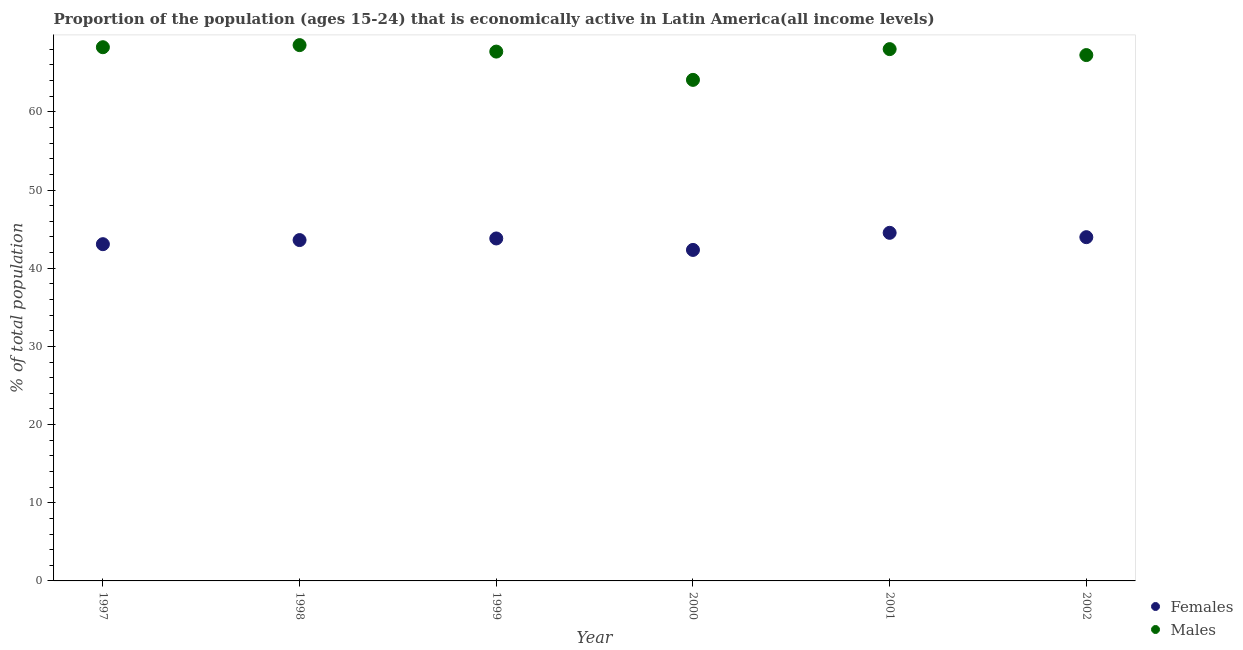How many different coloured dotlines are there?
Provide a succinct answer. 2. What is the percentage of economically active female population in 1998?
Offer a terse response. 43.6. Across all years, what is the maximum percentage of economically active female population?
Keep it short and to the point. 44.53. Across all years, what is the minimum percentage of economically active female population?
Offer a terse response. 42.34. What is the total percentage of economically active female population in the graph?
Ensure brevity in your answer.  261.32. What is the difference between the percentage of economically active male population in 1998 and that in 1999?
Keep it short and to the point. 0.83. What is the difference between the percentage of economically active male population in 1999 and the percentage of economically active female population in 2002?
Offer a very short reply. 23.74. What is the average percentage of economically active male population per year?
Provide a succinct answer. 67.32. In the year 1999, what is the difference between the percentage of economically active male population and percentage of economically active female population?
Your answer should be compact. 23.9. What is the ratio of the percentage of economically active female population in 1997 to that in 2001?
Keep it short and to the point. 0.97. What is the difference between the highest and the second highest percentage of economically active female population?
Give a very brief answer. 0.56. What is the difference between the highest and the lowest percentage of economically active male population?
Give a very brief answer. 4.45. Does the percentage of economically active female population monotonically increase over the years?
Your response must be concise. No. Is the percentage of economically active female population strictly less than the percentage of economically active male population over the years?
Your answer should be very brief. Yes. How many dotlines are there?
Give a very brief answer. 2. How many years are there in the graph?
Provide a succinct answer. 6. What is the difference between two consecutive major ticks on the Y-axis?
Ensure brevity in your answer.  10. Are the values on the major ticks of Y-axis written in scientific E-notation?
Offer a very short reply. No. Does the graph contain grids?
Give a very brief answer. No. What is the title of the graph?
Provide a succinct answer. Proportion of the population (ages 15-24) that is economically active in Latin America(all income levels). Does "External balance on goods" appear as one of the legend labels in the graph?
Your answer should be very brief. No. What is the label or title of the Y-axis?
Provide a succinct answer. % of total population. What is the % of total population in Females in 1997?
Give a very brief answer. 43.07. What is the % of total population in Males in 1997?
Your answer should be compact. 68.27. What is the % of total population in Females in 1998?
Your answer should be compact. 43.6. What is the % of total population in Males in 1998?
Provide a succinct answer. 68.54. What is the % of total population in Females in 1999?
Make the answer very short. 43.81. What is the % of total population in Males in 1999?
Keep it short and to the point. 67.71. What is the % of total population of Females in 2000?
Provide a short and direct response. 42.34. What is the % of total population of Males in 2000?
Give a very brief answer. 64.09. What is the % of total population of Females in 2001?
Offer a very short reply. 44.53. What is the % of total population of Males in 2001?
Offer a very short reply. 68.03. What is the % of total population in Females in 2002?
Your response must be concise. 43.97. What is the % of total population of Males in 2002?
Offer a terse response. 67.26. Across all years, what is the maximum % of total population in Females?
Provide a short and direct response. 44.53. Across all years, what is the maximum % of total population in Males?
Give a very brief answer. 68.54. Across all years, what is the minimum % of total population in Females?
Make the answer very short. 42.34. Across all years, what is the minimum % of total population in Males?
Your answer should be very brief. 64.09. What is the total % of total population in Females in the graph?
Offer a very short reply. 261.32. What is the total % of total population of Males in the graph?
Your response must be concise. 403.9. What is the difference between the % of total population in Females in 1997 and that in 1998?
Offer a very short reply. -0.53. What is the difference between the % of total population in Males in 1997 and that in 1998?
Your answer should be compact. -0.27. What is the difference between the % of total population of Females in 1997 and that in 1999?
Give a very brief answer. -0.73. What is the difference between the % of total population of Males in 1997 and that in 1999?
Your answer should be very brief. 0.56. What is the difference between the % of total population of Females in 1997 and that in 2000?
Your answer should be compact. 0.73. What is the difference between the % of total population in Males in 1997 and that in 2000?
Offer a very short reply. 4.18. What is the difference between the % of total population of Females in 1997 and that in 2001?
Keep it short and to the point. -1.45. What is the difference between the % of total population of Males in 1997 and that in 2001?
Provide a short and direct response. 0.24. What is the difference between the % of total population in Females in 1997 and that in 2002?
Give a very brief answer. -0.9. What is the difference between the % of total population in Females in 1998 and that in 1999?
Provide a succinct answer. -0.21. What is the difference between the % of total population of Males in 1998 and that in 1999?
Keep it short and to the point. 0.83. What is the difference between the % of total population of Females in 1998 and that in 2000?
Keep it short and to the point. 1.26. What is the difference between the % of total population in Males in 1998 and that in 2000?
Offer a very short reply. 4.45. What is the difference between the % of total population of Females in 1998 and that in 2001?
Your response must be concise. -0.93. What is the difference between the % of total population in Males in 1998 and that in 2001?
Your response must be concise. 0.51. What is the difference between the % of total population of Females in 1998 and that in 2002?
Make the answer very short. -0.37. What is the difference between the % of total population in Males in 1998 and that in 2002?
Give a very brief answer. 1.27. What is the difference between the % of total population of Females in 1999 and that in 2000?
Your answer should be compact. 1.47. What is the difference between the % of total population in Males in 1999 and that in 2000?
Ensure brevity in your answer.  3.62. What is the difference between the % of total population in Females in 1999 and that in 2001?
Keep it short and to the point. -0.72. What is the difference between the % of total population of Males in 1999 and that in 2001?
Your response must be concise. -0.32. What is the difference between the % of total population in Females in 1999 and that in 2002?
Give a very brief answer. -0.17. What is the difference between the % of total population of Males in 1999 and that in 2002?
Your answer should be compact. 0.44. What is the difference between the % of total population of Females in 2000 and that in 2001?
Provide a succinct answer. -2.19. What is the difference between the % of total population in Males in 2000 and that in 2001?
Keep it short and to the point. -3.93. What is the difference between the % of total population in Females in 2000 and that in 2002?
Make the answer very short. -1.63. What is the difference between the % of total population of Males in 2000 and that in 2002?
Offer a terse response. -3.17. What is the difference between the % of total population in Females in 2001 and that in 2002?
Your answer should be compact. 0.56. What is the difference between the % of total population in Males in 2001 and that in 2002?
Keep it short and to the point. 0.76. What is the difference between the % of total population in Females in 1997 and the % of total population in Males in 1998?
Your answer should be compact. -25.46. What is the difference between the % of total population in Females in 1997 and the % of total population in Males in 1999?
Offer a terse response. -24.63. What is the difference between the % of total population of Females in 1997 and the % of total population of Males in 2000?
Provide a succinct answer. -21.02. What is the difference between the % of total population in Females in 1997 and the % of total population in Males in 2001?
Keep it short and to the point. -24.95. What is the difference between the % of total population of Females in 1997 and the % of total population of Males in 2002?
Make the answer very short. -24.19. What is the difference between the % of total population of Females in 1998 and the % of total population of Males in 1999?
Provide a short and direct response. -24.11. What is the difference between the % of total population in Females in 1998 and the % of total population in Males in 2000?
Your response must be concise. -20.49. What is the difference between the % of total population of Females in 1998 and the % of total population of Males in 2001?
Make the answer very short. -24.43. What is the difference between the % of total population of Females in 1998 and the % of total population of Males in 2002?
Give a very brief answer. -23.66. What is the difference between the % of total population of Females in 1999 and the % of total population of Males in 2000?
Offer a terse response. -20.29. What is the difference between the % of total population in Females in 1999 and the % of total population in Males in 2001?
Your answer should be compact. -24.22. What is the difference between the % of total population in Females in 1999 and the % of total population in Males in 2002?
Your answer should be compact. -23.46. What is the difference between the % of total population of Females in 2000 and the % of total population of Males in 2001?
Offer a terse response. -25.69. What is the difference between the % of total population in Females in 2000 and the % of total population in Males in 2002?
Keep it short and to the point. -24.92. What is the difference between the % of total population of Females in 2001 and the % of total population of Males in 2002?
Ensure brevity in your answer.  -22.74. What is the average % of total population in Females per year?
Make the answer very short. 43.55. What is the average % of total population in Males per year?
Offer a terse response. 67.32. In the year 1997, what is the difference between the % of total population in Females and % of total population in Males?
Make the answer very short. -25.2. In the year 1998, what is the difference between the % of total population in Females and % of total population in Males?
Make the answer very short. -24.94. In the year 1999, what is the difference between the % of total population in Females and % of total population in Males?
Offer a terse response. -23.9. In the year 2000, what is the difference between the % of total population of Females and % of total population of Males?
Keep it short and to the point. -21.75. In the year 2001, what is the difference between the % of total population in Females and % of total population in Males?
Make the answer very short. -23.5. In the year 2002, what is the difference between the % of total population in Females and % of total population in Males?
Your response must be concise. -23.29. What is the ratio of the % of total population in Females in 1997 to that in 1998?
Keep it short and to the point. 0.99. What is the ratio of the % of total population of Males in 1997 to that in 1998?
Keep it short and to the point. 1. What is the ratio of the % of total population of Females in 1997 to that in 1999?
Offer a very short reply. 0.98. What is the ratio of the % of total population in Males in 1997 to that in 1999?
Offer a terse response. 1.01. What is the ratio of the % of total population in Females in 1997 to that in 2000?
Your response must be concise. 1.02. What is the ratio of the % of total population in Males in 1997 to that in 2000?
Make the answer very short. 1.07. What is the ratio of the % of total population in Females in 1997 to that in 2001?
Offer a terse response. 0.97. What is the ratio of the % of total population in Males in 1997 to that in 2001?
Provide a short and direct response. 1. What is the ratio of the % of total population of Females in 1997 to that in 2002?
Provide a succinct answer. 0.98. What is the ratio of the % of total population in Males in 1997 to that in 2002?
Your answer should be very brief. 1.01. What is the ratio of the % of total population of Males in 1998 to that in 1999?
Make the answer very short. 1.01. What is the ratio of the % of total population of Females in 1998 to that in 2000?
Make the answer very short. 1.03. What is the ratio of the % of total population in Males in 1998 to that in 2000?
Ensure brevity in your answer.  1.07. What is the ratio of the % of total population of Females in 1998 to that in 2001?
Provide a succinct answer. 0.98. What is the ratio of the % of total population of Males in 1998 to that in 2001?
Your answer should be very brief. 1.01. What is the ratio of the % of total population in Males in 1998 to that in 2002?
Your response must be concise. 1.02. What is the ratio of the % of total population in Females in 1999 to that in 2000?
Offer a very short reply. 1.03. What is the ratio of the % of total population of Males in 1999 to that in 2000?
Your answer should be compact. 1.06. What is the ratio of the % of total population in Females in 1999 to that in 2001?
Make the answer very short. 0.98. What is the ratio of the % of total population in Males in 1999 to that in 2001?
Offer a terse response. 1. What is the ratio of the % of total population in Males in 1999 to that in 2002?
Provide a succinct answer. 1.01. What is the ratio of the % of total population in Females in 2000 to that in 2001?
Give a very brief answer. 0.95. What is the ratio of the % of total population in Males in 2000 to that in 2001?
Your answer should be compact. 0.94. What is the ratio of the % of total population of Females in 2000 to that in 2002?
Give a very brief answer. 0.96. What is the ratio of the % of total population in Males in 2000 to that in 2002?
Offer a very short reply. 0.95. What is the ratio of the % of total population in Females in 2001 to that in 2002?
Your response must be concise. 1.01. What is the ratio of the % of total population of Males in 2001 to that in 2002?
Give a very brief answer. 1.01. What is the difference between the highest and the second highest % of total population in Females?
Offer a terse response. 0.56. What is the difference between the highest and the second highest % of total population of Males?
Your response must be concise. 0.27. What is the difference between the highest and the lowest % of total population in Females?
Make the answer very short. 2.19. What is the difference between the highest and the lowest % of total population of Males?
Your response must be concise. 4.45. 